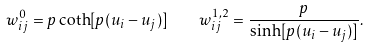Convert formula to latex. <formula><loc_0><loc_0><loc_500><loc_500>w _ { i j } ^ { 0 } = p \coth [ p ( u _ { i } - u _ { j } ) ] \quad w _ { i j } ^ { 1 , 2 } = \frac { p } { \sinh [ p ( u _ { i } - u _ { j } ) ] } .</formula> 